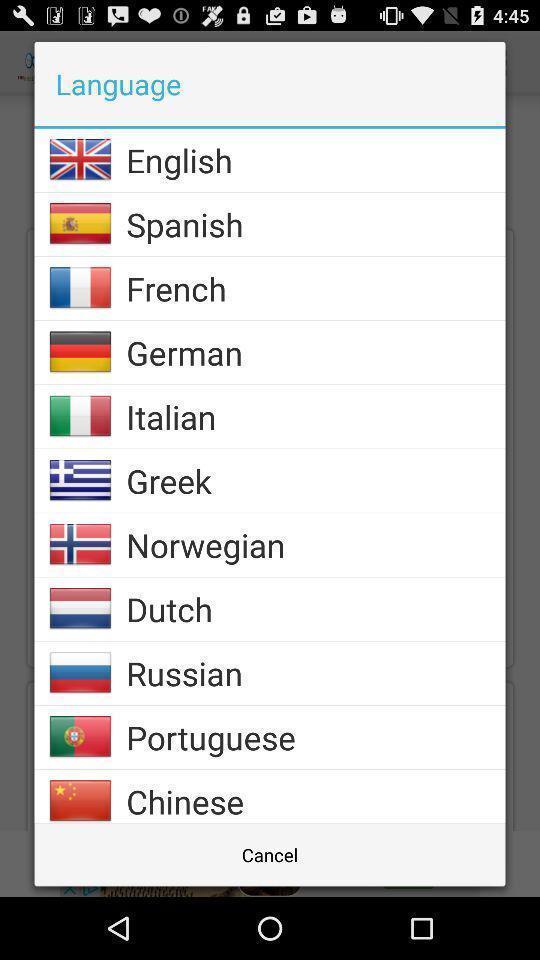What is the overall content of this screenshot? Pop-up showing to a select language. 